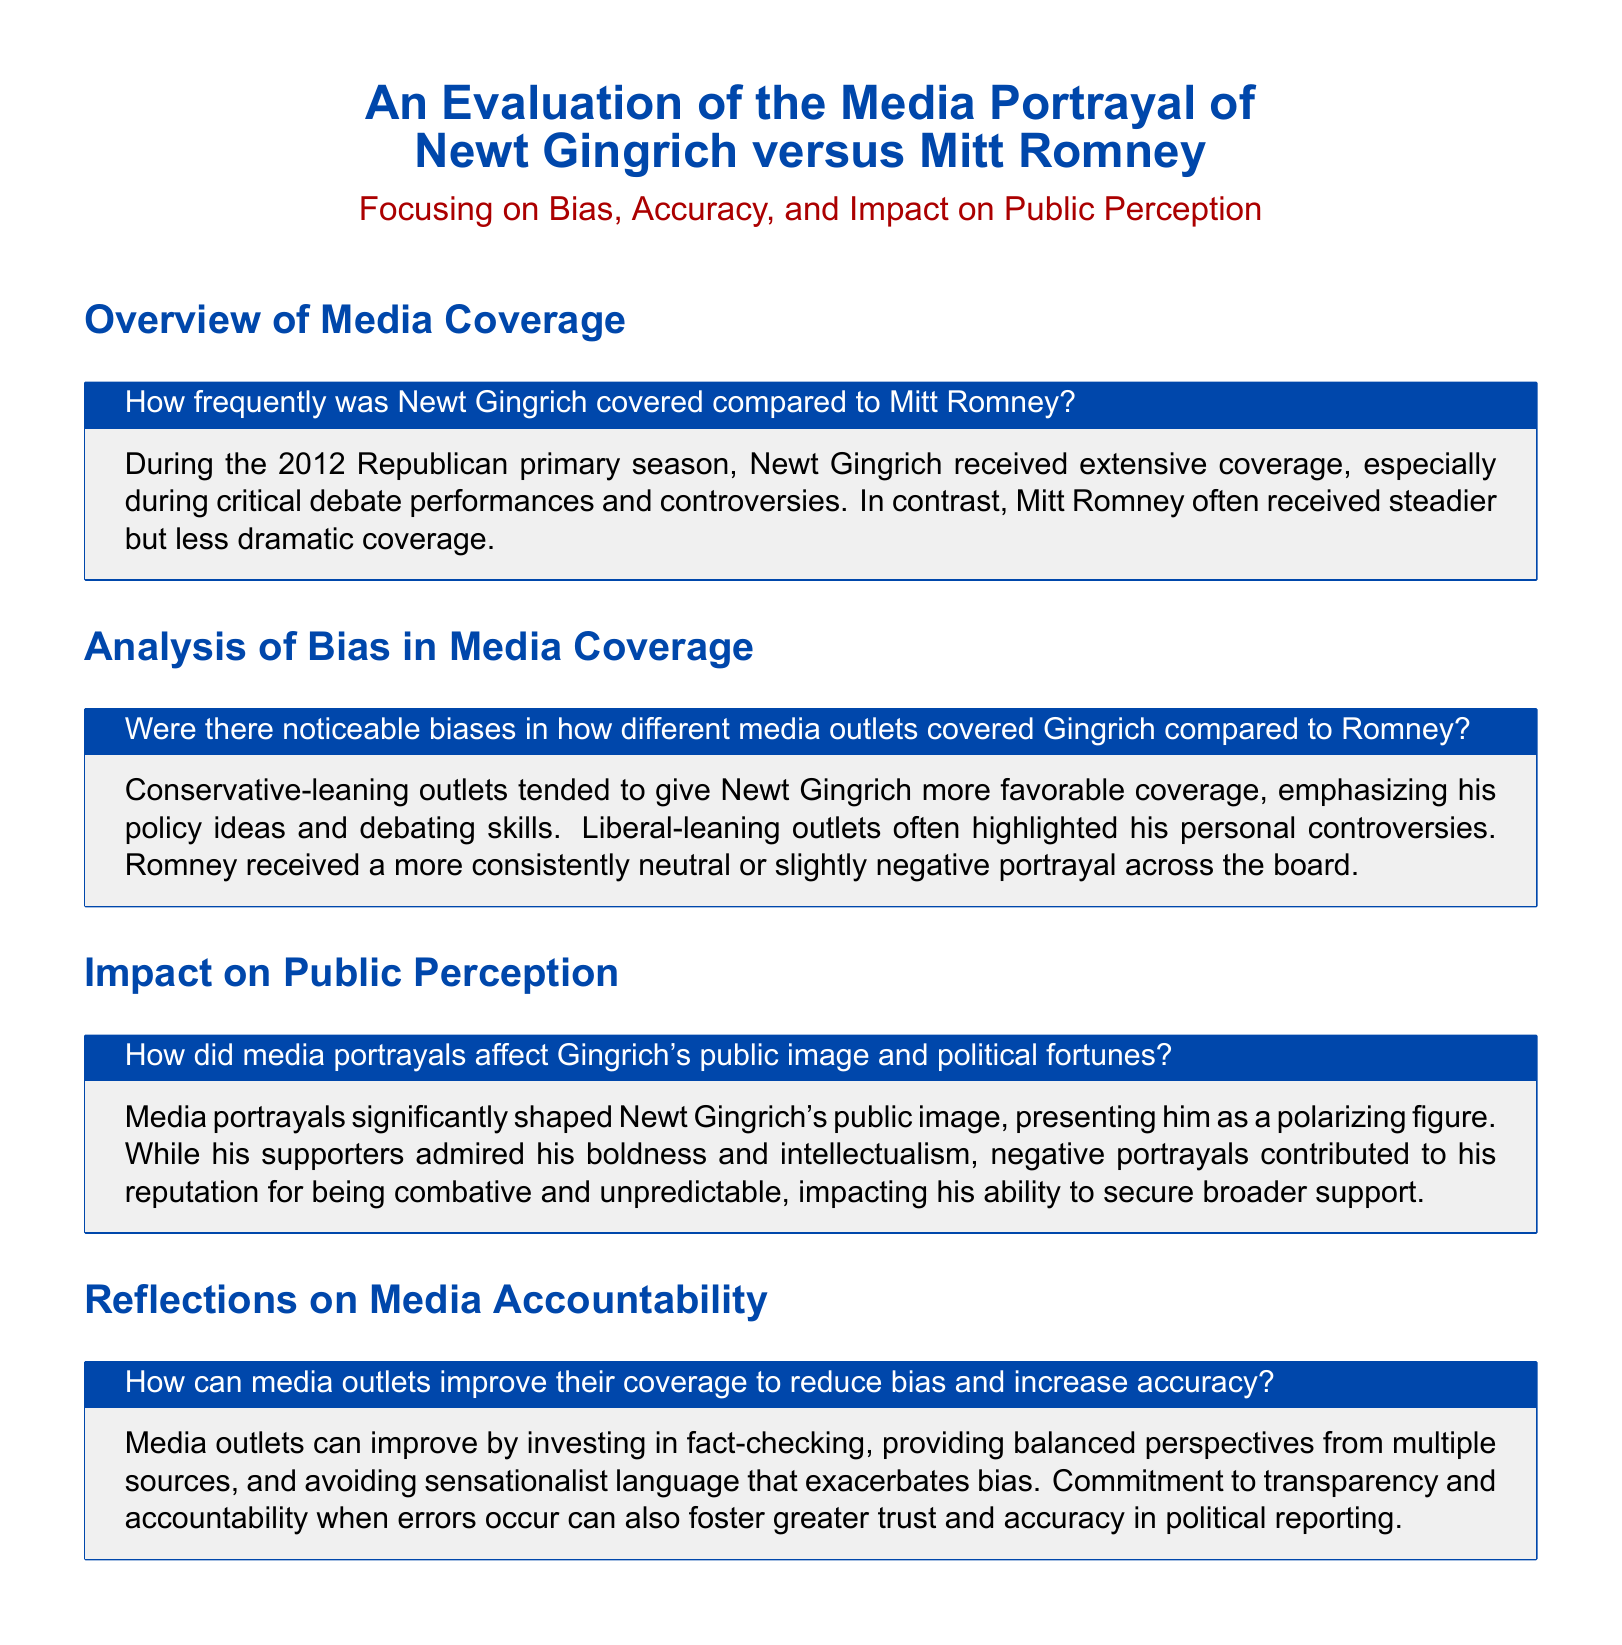How frequently was Newt Gingrich covered compared to Mitt Romney? The document states that Newt Gingrich received extensive coverage, especially during critical debate performances and controversies, while Mitt Romney received steadier but less dramatic coverage.
Answer: Extensive coverage Were there noticeable biases in how different media outlets covered Gingrich compared to Romney? The analysis reveals that conservative-leaning outlets favored Gingrich's policy ideas, while liberal-leaning outlets focused on his controversies, contrasting with Romney's neutral portrayal.
Answer: Yes How did media portrayals affect Gingrich's public image and political fortunes? The document emphasizes that media portrayals shaped Gingrich's image as polarizing, with supporters admiring him but negative portrayals impacting broader support.
Answer: Polarizing figure What can media outlets do to improve their coverage? The text suggests that media can enhance coverage by investing in fact-checking, providing balanced perspectives, and avoiding sensationalist language.
Answer: Improve fact-checking What color is used for the title "An Evaluation of the Media Portrayal of Newt Gingrich versus Mitt Romney"? The document specifies that the color used for the title is gingrich blue.
Answer: Gingrich blue How are the sections in the document titled? The document presents sections labeled as "Overview of Media Coverage," "Analysis of Bias in Media Coverage," "Impact on Public Perception," and "Reflections on Media Accountability."
Answer: Title sections What is the primary focus of the document? The document focuses primarily on bias, accuracy, and impact on public perception regarding Gingrich and Romney's media portrayals.
Answer: Bias, accuracy, impact 